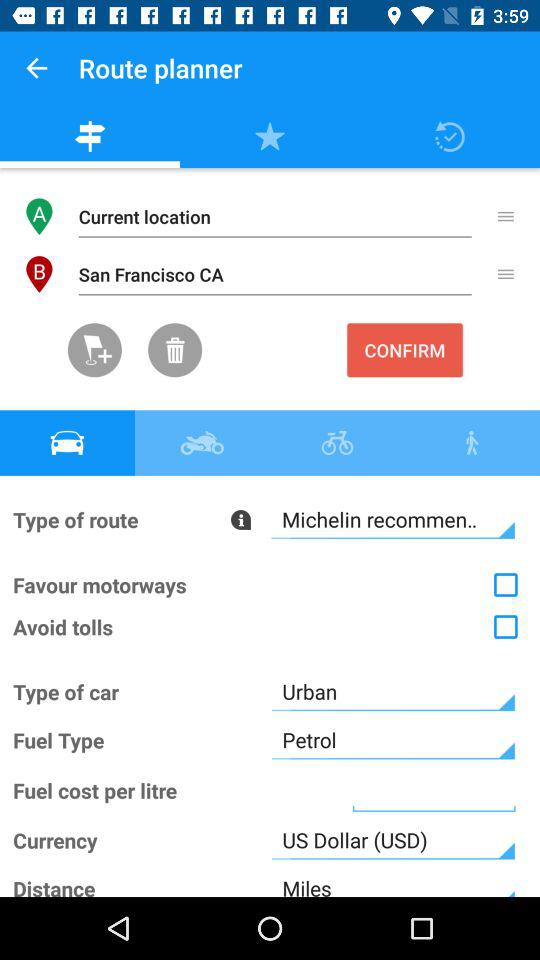What is the destination location? The destination location is San Francisco, CA. 